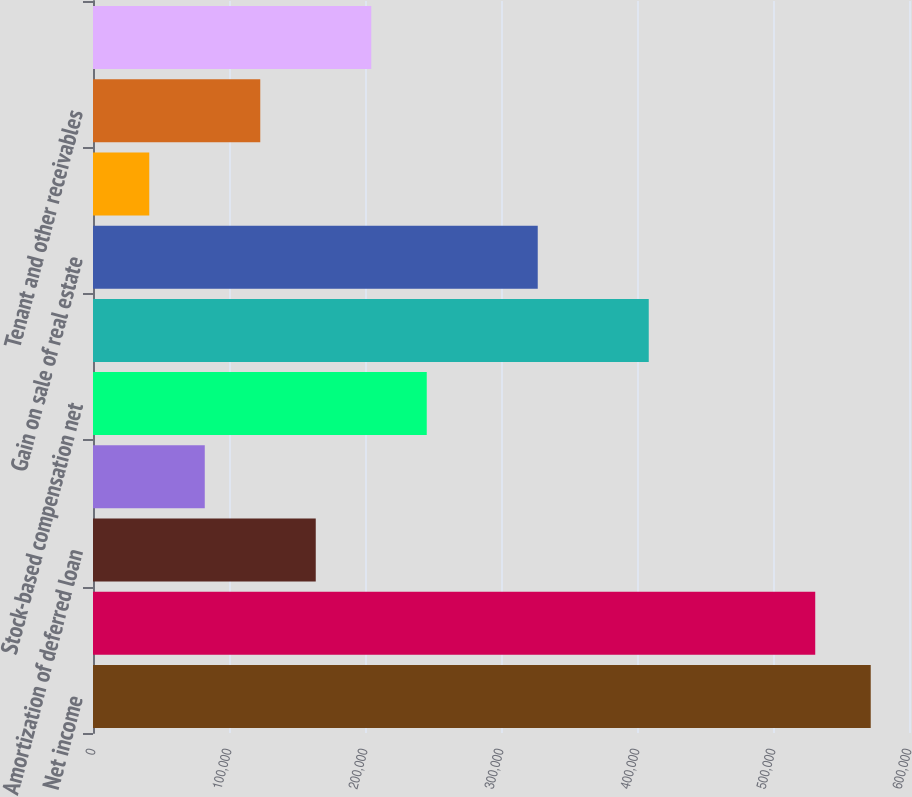<chart> <loc_0><loc_0><loc_500><loc_500><bar_chart><fcel>Net income<fcel>Depreciation and amortization<fcel>Amortization of deferred loan<fcel>(Accretion) and amortization<fcel>Stock-based compensation net<fcel>Equity in income of<fcel>Gain on sale of real estate<fcel>Realized and unrealized gain<fcel>Tenant and other receivables<fcel>Deferred leasing costs<nl><fcel>571859<fcel>531052<fcel>163791<fcel>82177.6<fcel>245405<fcel>408632<fcel>327018<fcel>41370.8<fcel>122984<fcel>204598<nl></chart> 